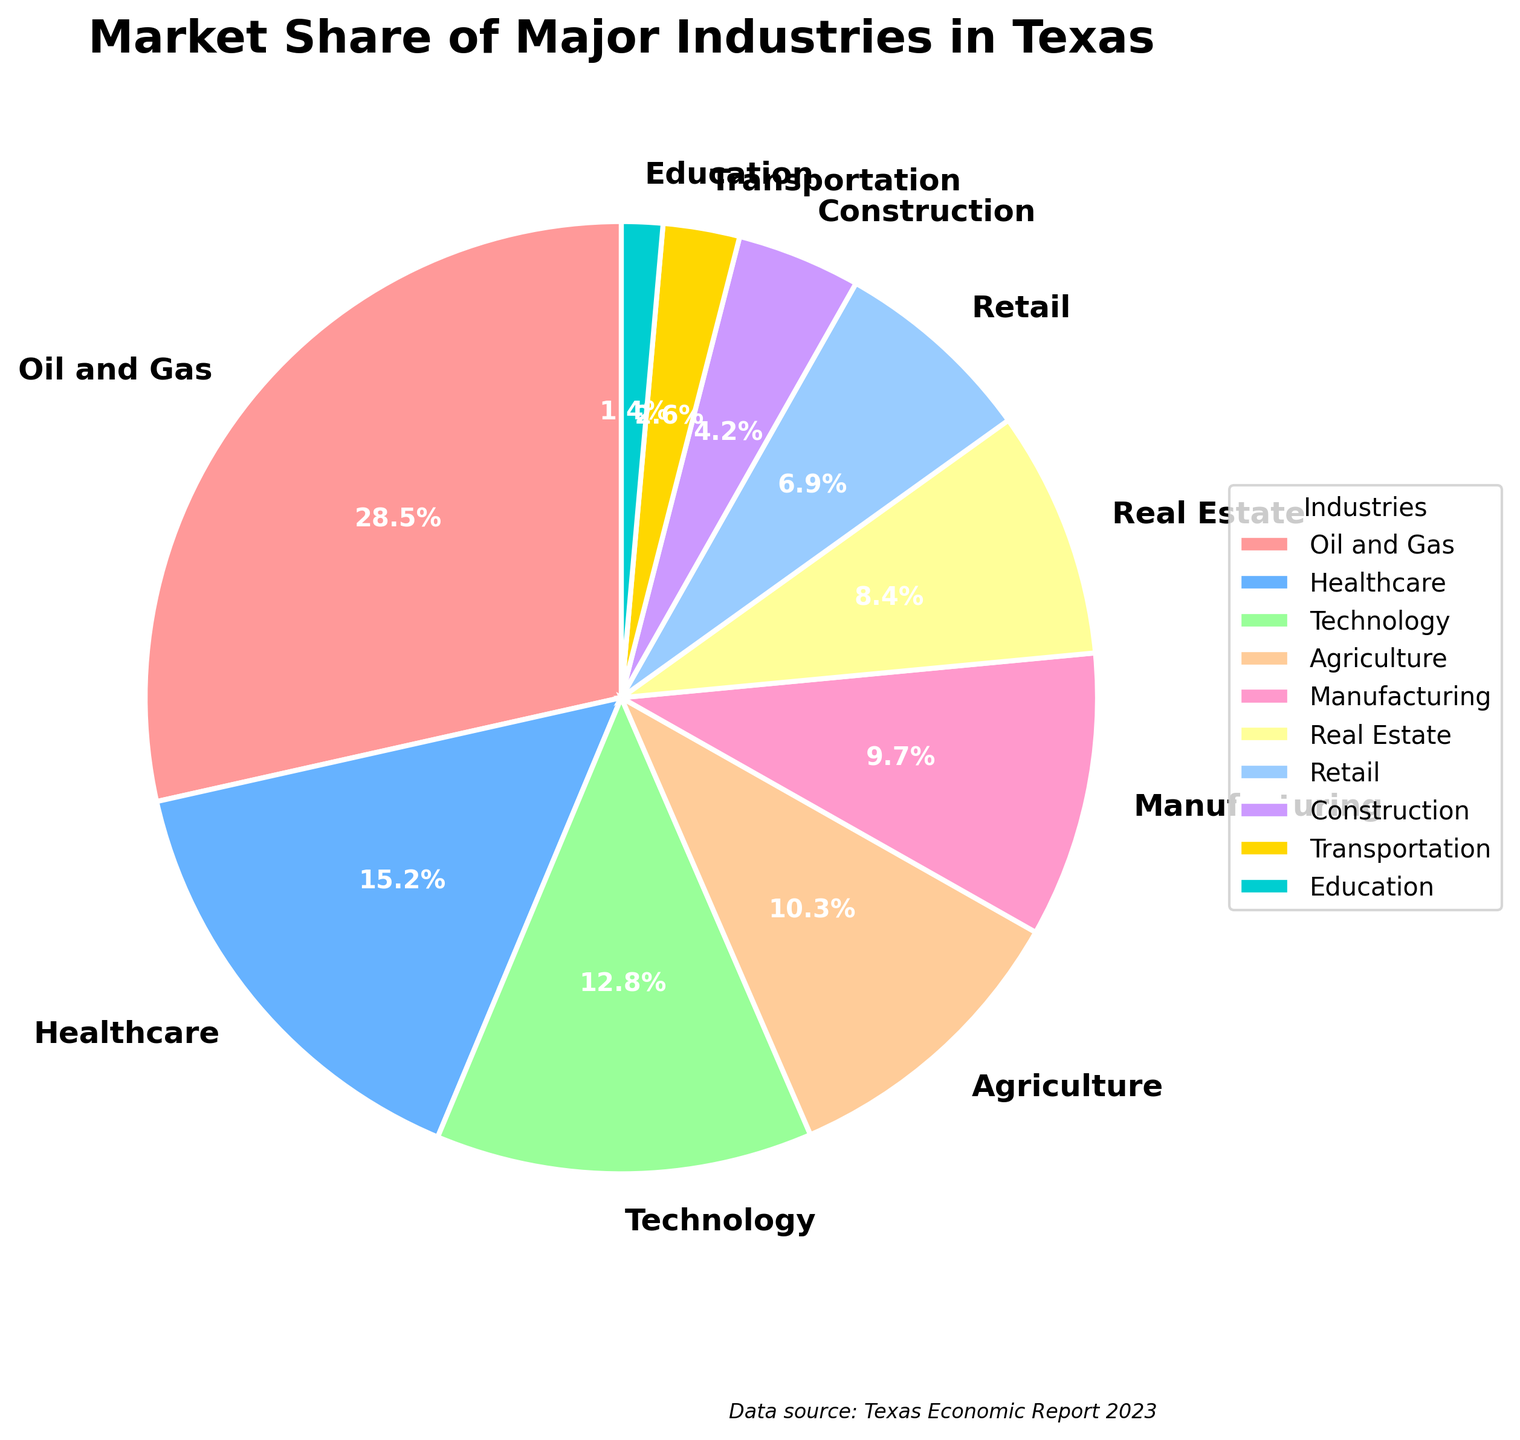What industry holds the largest market share in Texas? Observing the pie chart, the largest wedge that occupies the most space is labelled "Oil and Gas." Thus, Oil and Gas has the largest market share.
Answer: Oil and Gas What percentage of the market is shared by Agriculture, Construction, and Transportation combined? Adding the market shares for Agriculture (10.3%), Construction (4.2%), and Transportation (2.6%): 10.3 + 4.2 + 2.6 = 17.1
Answer: 17.1% Which industry has a smaller market share: Real Estate or Manufacturing? Comparing the wedges for Real Estate (8.4%) and Manufacturing (9.7%), the Real Estate wedge is smaller.
Answer: Real Estate By how much does the Oil and Gas market share exceed the Technology market share? Subtracting the Technology market share (12.8%) from the Oil and Gas market share (28.5%): 28.5 - 12.8 = 15.7
Answer: 15.7% What is the total market share of the top three industries? Adding the market shares of the top three industries: Oil and Gas (28.5%), Healthcare (15.2%), and Technology (12.8%): 28.5 + 15.2 + 12.8 = 56.5
Answer: 56.5% Which industry has a larger market share: Retail or Education? Comparing the wedges for Retail (6.9%) and Education (1.4%), the Retail wedge is larger.
Answer: Retail What is the sum of the market shares for the least three contributing industries? Summing up the market shares for the least three industries: Construction (4.2%), Transportation (2.6%), and Education (1.4%): 4.2 + 2.6 + 1.4 = 8.2
Answer: 8.2% What industry has a market share closest to 10%? Observing the pie chart, the Agriculture wedge is closest to the 10% mark with a share of 10.3%.
Answer: Agriculture How much more market share does Healthcare have compared to Retail? Subtracting the Retail market share (6.9%) from the Healthcare market share (15.2%): 15.2 - 6.9 = 8.3
Answer: 8.3% Which industries have a market share greater than 10% but less than 20%? Observing the pie chart, the industries meeting this criterion are Healthcare (15.2%), Technology (12.8%), and Agriculture (10.3%).
Answer: Healthcare, Technology, Agriculture 